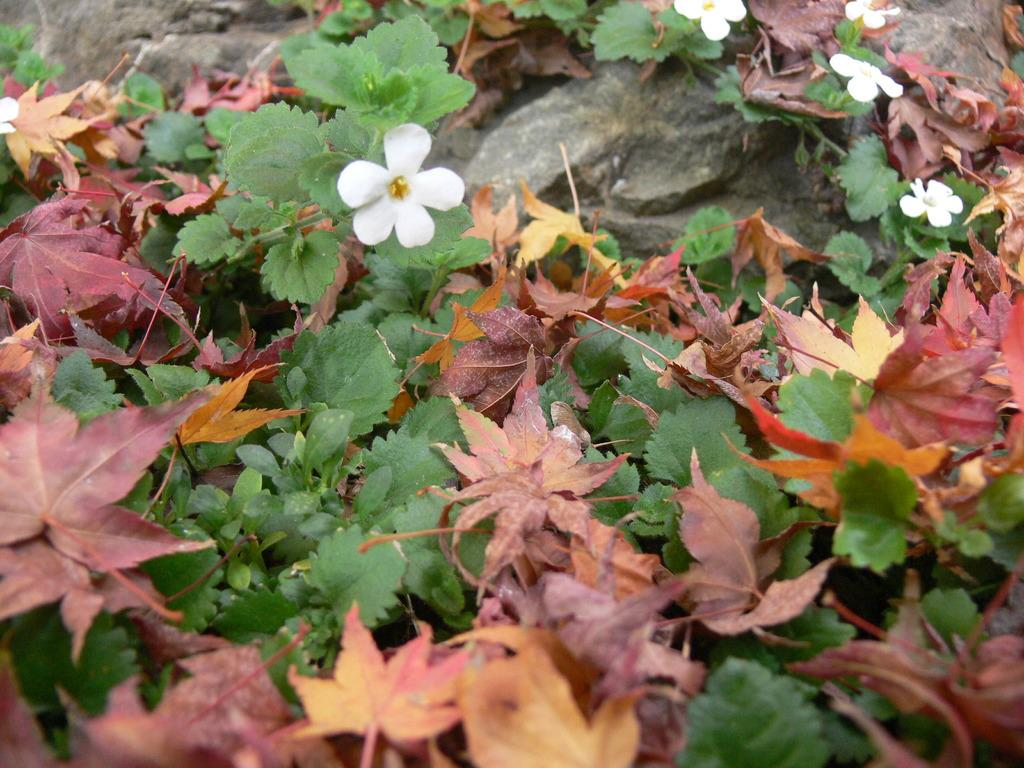What type of natural material can be seen in the image? There are dry leaves in the image. What type of plants are present in the image? There are plants with white flowers in the image. What inorganic object is visible in the image? There is a rock in the image. What type of calculator can be seen in the image? There is no calculator present in the image. Can you tell me how the plants with white flowers are expressing anger in the image? The plants with white flowers are not expressing anger, as plants do not have emotions. 